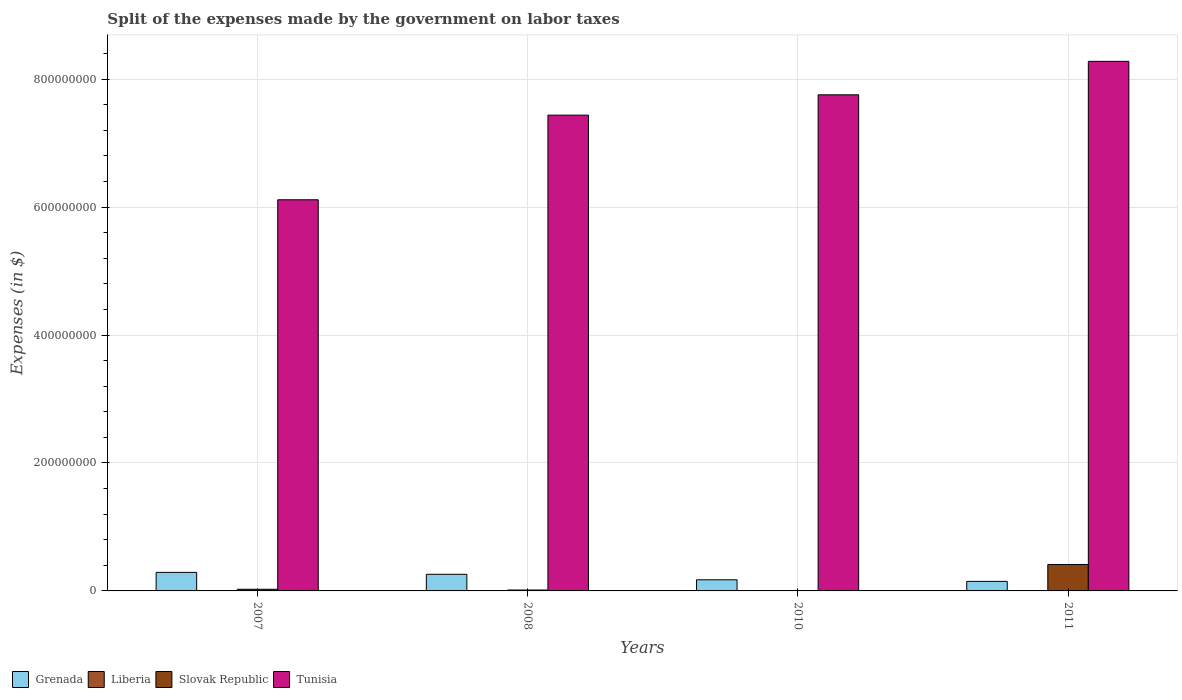How many bars are there on the 3rd tick from the left?
Offer a terse response. 4. What is the label of the 1st group of bars from the left?
Give a very brief answer. 2007. What is the expenses made by the government on labor taxes in Liberia in 2011?
Keep it short and to the point. 1.69e+05. Across all years, what is the maximum expenses made by the government on labor taxes in Grenada?
Keep it short and to the point. 2.90e+07. Across all years, what is the minimum expenses made by the government on labor taxes in Grenada?
Keep it short and to the point. 1.49e+07. What is the total expenses made by the government on labor taxes in Liberia in the graph?
Offer a very short reply. 3.91e+05. What is the difference between the expenses made by the government on labor taxes in Liberia in 2007 and that in 2011?
Your answer should be compact. -1.54e+05. What is the difference between the expenses made by the government on labor taxes in Grenada in 2011 and the expenses made by the government on labor taxes in Slovak Republic in 2010?
Provide a succinct answer. 1.45e+07. What is the average expenses made by the government on labor taxes in Grenada per year?
Ensure brevity in your answer.  2.18e+07. In the year 2010, what is the difference between the expenses made by the government on labor taxes in Liberia and expenses made by the government on labor taxes in Tunisia?
Your answer should be very brief. -7.75e+08. In how many years, is the expenses made by the government on labor taxes in Tunisia greater than 280000000 $?
Your answer should be very brief. 4. What is the ratio of the expenses made by the government on labor taxes in Tunisia in 2007 to that in 2010?
Offer a terse response. 0.79. What is the difference between the highest and the second highest expenses made by the government on labor taxes in Tunisia?
Keep it short and to the point. 5.23e+07. What is the difference between the highest and the lowest expenses made by the government on labor taxes in Grenada?
Your response must be concise. 1.41e+07. In how many years, is the expenses made by the government on labor taxes in Grenada greater than the average expenses made by the government on labor taxes in Grenada taken over all years?
Make the answer very short. 2. Is the sum of the expenses made by the government on labor taxes in Tunisia in 2008 and 2011 greater than the maximum expenses made by the government on labor taxes in Liberia across all years?
Provide a short and direct response. Yes. What does the 4th bar from the left in 2010 represents?
Offer a terse response. Tunisia. What does the 2nd bar from the right in 2011 represents?
Offer a very short reply. Slovak Republic. Is it the case that in every year, the sum of the expenses made by the government on labor taxes in Slovak Republic and expenses made by the government on labor taxes in Grenada is greater than the expenses made by the government on labor taxes in Tunisia?
Provide a succinct answer. No. How many bars are there?
Your answer should be very brief. 16. What is the difference between two consecutive major ticks on the Y-axis?
Ensure brevity in your answer.  2.00e+08. Does the graph contain any zero values?
Your answer should be very brief. No. How many legend labels are there?
Offer a terse response. 4. How are the legend labels stacked?
Give a very brief answer. Horizontal. What is the title of the graph?
Offer a very short reply. Split of the expenses made by the government on labor taxes. What is the label or title of the X-axis?
Provide a short and direct response. Years. What is the label or title of the Y-axis?
Your answer should be compact. Expenses (in $). What is the Expenses (in $) in Grenada in 2007?
Your answer should be compact. 2.90e+07. What is the Expenses (in $) in Liberia in 2007?
Ensure brevity in your answer.  1.49e+04. What is the Expenses (in $) of Slovak Republic in 2007?
Your response must be concise. 2.58e+06. What is the Expenses (in $) in Tunisia in 2007?
Your answer should be very brief. 6.12e+08. What is the Expenses (in $) of Grenada in 2008?
Your answer should be very brief. 2.60e+07. What is the Expenses (in $) in Liberia in 2008?
Provide a short and direct response. 2.34e+04. What is the Expenses (in $) of Slovak Republic in 2008?
Make the answer very short. 1.39e+06. What is the Expenses (in $) in Tunisia in 2008?
Offer a terse response. 7.44e+08. What is the Expenses (in $) of Grenada in 2010?
Your answer should be compact. 1.74e+07. What is the Expenses (in $) of Liberia in 2010?
Offer a terse response. 1.84e+05. What is the Expenses (in $) in Slovak Republic in 2010?
Your answer should be compact. 3.61e+05. What is the Expenses (in $) of Tunisia in 2010?
Your response must be concise. 7.76e+08. What is the Expenses (in $) in Grenada in 2011?
Provide a succinct answer. 1.49e+07. What is the Expenses (in $) of Liberia in 2011?
Make the answer very short. 1.69e+05. What is the Expenses (in $) in Slovak Republic in 2011?
Ensure brevity in your answer.  4.13e+07. What is the Expenses (in $) of Tunisia in 2011?
Ensure brevity in your answer.  8.28e+08. Across all years, what is the maximum Expenses (in $) in Grenada?
Provide a short and direct response. 2.90e+07. Across all years, what is the maximum Expenses (in $) in Liberia?
Your response must be concise. 1.84e+05. Across all years, what is the maximum Expenses (in $) of Slovak Republic?
Provide a succinct answer. 4.13e+07. Across all years, what is the maximum Expenses (in $) of Tunisia?
Give a very brief answer. 8.28e+08. Across all years, what is the minimum Expenses (in $) in Grenada?
Your answer should be compact. 1.49e+07. Across all years, what is the minimum Expenses (in $) of Liberia?
Your response must be concise. 1.49e+04. Across all years, what is the minimum Expenses (in $) in Slovak Republic?
Make the answer very short. 3.61e+05. Across all years, what is the minimum Expenses (in $) in Tunisia?
Offer a terse response. 6.12e+08. What is the total Expenses (in $) in Grenada in the graph?
Give a very brief answer. 8.73e+07. What is the total Expenses (in $) of Liberia in the graph?
Ensure brevity in your answer.  3.91e+05. What is the total Expenses (in $) in Slovak Republic in the graph?
Give a very brief answer. 4.57e+07. What is the total Expenses (in $) in Tunisia in the graph?
Your response must be concise. 2.96e+09. What is the difference between the Expenses (in $) of Grenada in 2007 and that in 2008?
Give a very brief answer. 3.00e+06. What is the difference between the Expenses (in $) in Liberia in 2007 and that in 2008?
Your answer should be very brief. -8521.28. What is the difference between the Expenses (in $) of Slovak Republic in 2007 and that in 2008?
Your answer should be very brief. 1.19e+06. What is the difference between the Expenses (in $) in Tunisia in 2007 and that in 2008?
Your answer should be very brief. -1.32e+08. What is the difference between the Expenses (in $) of Grenada in 2007 and that in 2010?
Offer a very short reply. 1.16e+07. What is the difference between the Expenses (in $) of Liberia in 2007 and that in 2010?
Your answer should be very brief. -1.69e+05. What is the difference between the Expenses (in $) of Slovak Republic in 2007 and that in 2010?
Your answer should be very brief. 2.22e+06. What is the difference between the Expenses (in $) of Tunisia in 2007 and that in 2010?
Provide a short and direct response. -1.64e+08. What is the difference between the Expenses (in $) in Grenada in 2007 and that in 2011?
Provide a succinct answer. 1.41e+07. What is the difference between the Expenses (in $) in Liberia in 2007 and that in 2011?
Ensure brevity in your answer.  -1.54e+05. What is the difference between the Expenses (in $) of Slovak Republic in 2007 and that in 2011?
Your answer should be compact. -3.87e+07. What is the difference between the Expenses (in $) of Tunisia in 2007 and that in 2011?
Offer a very short reply. -2.16e+08. What is the difference between the Expenses (in $) in Grenada in 2008 and that in 2010?
Give a very brief answer. 8.60e+06. What is the difference between the Expenses (in $) of Liberia in 2008 and that in 2010?
Your answer should be compact. -1.61e+05. What is the difference between the Expenses (in $) in Slovak Republic in 2008 and that in 2010?
Ensure brevity in your answer.  1.03e+06. What is the difference between the Expenses (in $) of Tunisia in 2008 and that in 2010?
Provide a short and direct response. -3.18e+07. What is the difference between the Expenses (in $) in Grenada in 2008 and that in 2011?
Make the answer very short. 1.11e+07. What is the difference between the Expenses (in $) in Liberia in 2008 and that in 2011?
Provide a short and direct response. -1.45e+05. What is the difference between the Expenses (in $) of Slovak Republic in 2008 and that in 2011?
Ensure brevity in your answer.  -3.99e+07. What is the difference between the Expenses (in $) of Tunisia in 2008 and that in 2011?
Ensure brevity in your answer.  -8.41e+07. What is the difference between the Expenses (in $) in Grenada in 2010 and that in 2011?
Make the answer very short. 2.50e+06. What is the difference between the Expenses (in $) in Liberia in 2010 and that in 2011?
Your answer should be very brief. 1.55e+04. What is the difference between the Expenses (in $) in Slovak Republic in 2010 and that in 2011?
Offer a very short reply. -4.10e+07. What is the difference between the Expenses (in $) of Tunisia in 2010 and that in 2011?
Your answer should be compact. -5.23e+07. What is the difference between the Expenses (in $) of Grenada in 2007 and the Expenses (in $) of Liberia in 2008?
Give a very brief answer. 2.90e+07. What is the difference between the Expenses (in $) of Grenada in 2007 and the Expenses (in $) of Slovak Republic in 2008?
Give a very brief answer. 2.76e+07. What is the difference between the Expenses (in $) in Grenada in 2007 and the Expenses (in $) in Tunisia in 2008?
Keep it short and to the point. -7.15e+08. What is the difference between the Expenses (in $) of Liberia in 2007 and the Expenses (in $) of Slovak Republic in 2008?
Your response must be concise. -1.38e+06. What is the difference between the Expenses (in $) of Liberia in 2007 and the Expenses (in $) of Tunisia in 2008?
Your answer should be compact. -7.44e+08. What is the difference between the Expenses (in $) in Slovak Republic in 2007 and the Expenses (in $) in Tunisia in 2008?
Offer a terse response. -7.41e+08. What is the difference between the Expenses (in $) in Grenada in 2007 and the Expenses (in $) in Liberia in 2010?
Make the answer very short. 2.88e+07. What is the difference between the Expenses (in $) in Grenada in 2007 and the Expenses (in $) in Slovak Republic in 2010?
Make the answer very short. 2.86e+07. What is the difference between the Expenses (in $) of Grenada in 2007 and the Expenses (in $) of Tunisia in 2010?
Ensure brevity in your answer.  -7.47e+08. What is the difference between the Expenses (in $) of Liberia in 2007 and the Expenses (in $) of Slovak Republic in 2010?
Make the answer very short. -3.46e+05. What is the difference between the Expenses (in $) of Liberia in 2007 and the Expenses (in $) of Tunisia in 2010?
Give a very brief answer. -7.76e+08. What is the difference between the Expenses (in $) in Slovak Republic in 2007 and the Expenses (in $) in Tunisia in 2010?
Make the answer very short. -7.73e+08. What is the difference between the Expenses (in $) in Grenada in 2007 and the Expenses (in $) in Liberia in 2011?
Offer a very short reply. 2.88e+07. What is the difference between the Expenses (in $) of Grenada in 2007 and the Expenses (in $) of Slovak Republic in 2011?
Provide a succinct answer. -1.23e+07. What is the difference between the Expenses (in $) in Grenada in 2007 and the Expenses (in $) in Tunisia in 2011?
Offer a terse response. -7.99e+08. What is the difference between the Expenses (in $) of Liberia in 2007 and the Expenses (in $) of Slovak Republic in 2011?
Give a very brief answer. -4.13e+07. What is the difference between the Expenses (in $) of Liberia in 2007 and the Expenses (in $) of Tunisia in 2011?
Offer a terse response. -8.28e+08. What is the difference between the Expenses (in $) in Slovak Republic in 2007 and the Expenses (in $) in Tunisia in 2011?
Provide a short and direct response. -8.25e+08. What is the difference between the Expenses (in $) of Grenada in 2008 and the Expenses (in $) of Liberia in 2010?
Give a very brief answer. 2.58e+07. What is the difference between the Expenses (in $) of Grenada in 2008 and the Expenses (in $) of Slovak Republic in 2010?
Ensure brevity in your answer.  2.56e+07. What is the difference between the Expenses (in $) in Grenada in 2008 and the Expenses (in $) in Tunisia in 2010?
Ensure brevity in your answer.  -7.50e+08. What is the difference between the Expenses (in $) in Liberia in 2008 and the Expenses (in $) in Slovak Republic in 2010?
Make the answer very short. -3.38e+05. What is the difference between the Expenses (in $) in Liberia in 2008 and the Expenses (in $) in Tunisia in 2010?
Make the answer very short. -7.76e+08. What is the difference between the Expenses (in $) in Slovak Republic in 2008 and the Expenses (in $) in Tunisia in 2010?
Provide a succinct answer. -7.74e+08. What is the difference between the Expenses (in $) in Grenada in 2008 and the Expenses (in $) in Liberia in 2011?
Offer a very short reply. 2.58e+07. What is the difference between the Expenses (in $) of Grenada in 2008 and the Expenses (in $) of Slovak Republic in 2011?
Give a very brief answer. -1.53e+07. What is the difference between the Expenses (in $) in Grenada in 2008 and the Expenses (in $) in Tunisia in 2011?
Offer a very short reply. -8.02e+08. What is the difference between the Expenses (in $) in Liberia in 2008 and the Expenses (in $) in Slovak Republic in 2011?
Your answer should be compact. -4.13e+07. What is the difference between the Expenses (in $) in Liberia in 2008 and the Expenses (in $) in Tunisia in 2011?
Your answer should be very brief. -8.28e+08. What is the difference between the Expenses (in $) in Slovak Republic in 2008 and the Expenses (in $) in Tunisia in 2011?
Offer a terse response. -8.27e+08. What is the difference between the Expenses (in $) in Grenada in 2010 and the Expenses (in $) in Liberia in 2011?
Provide a succinct answer. 1.72e+07. What is the difference between the Expenses (in $) in Grenada in 2010 and the Expenses (in $) in Slovak Republic in 2011?
Keep it short and to the point. -2.39e+07. What is the difference between the Expenses (in $) in Grenada in 2010 and the Expenses (in $) in Tunisia in 2011?
Ensure brevity in your answer.  -8.10e+08. What is the difference between the Expenses (in $) of Liberia in 2010 and the Expenses (in $) of Slovak Republic in 2011?
Offer a very short reply. -4.11e+07. What is the difference between the Expenses (in $) in Liberia in 2010 and the Expenses (in $) in Tunisia in 2011?
Provide a succinct answer. -8.28e+08. What is the difference between the Expenses (in $) of Slovak Republic in 2010 and the Expenses (in $) of Tunisia in 2011?
Keep it short and to the point. -8.28e+08. What is the average Expenses (in $) of Grenada per year?
Your answer should be very brief. 2.18e+07. What is the average Expenses (in $) in Liberia per year?
Give a very brief answer. 9.77e+04. What is the average Expenses (in $) in Slovak Republic per year?
Keep it short and to the point. 1.14e+07. What is the average Expenses (in $) of Tunisia per year?
Give a very brief answer. 7.40e+08. In the year 2007, what is the difference between the Expenses (in $) in Grenada and Expenses (in $) in Liberia?
Make the answer very short. 2.90e+07. In the year 2007, what is the difference between the Expenses (in $) of Grenada and Expenses (in $) of Slovak Republic?
Your answer should be compact. 2.64e+07. In the year 2007, what is the difference between the Expenses (in $) in Grenada and Expenses (in $) in Tunisia?
Give a very brief answer. -5.82e+08. In the year 2007, what is the difference between the Expenses (in $) of Liberia and Expenses (in $) of Slovak Republic?
Offer a terse response. -2.57e+06. In the year 2007, what is the difference between the Expenses (in $) of Liberia and Expenses (in $) of Tunisia?
Offer a very short reply. -6.11e+08. In the year 2007, what is the difference between the Expenses (in $) in Slovak Republic and Expenses (in $) in Tunisia?
Provide a succinct answer. -6.09e+08. In the year 2008, what is the difference between the Expenses (in $) in Grenada and Expenses (in $) in Liberia?
Give a very brief answer. 2.60e+07. In the year 2008, what is the difference between the Expenses (in $) in Grenada and Expenses (in $) in Slovak Republic?
Ensure brevity in your answer.  2.46e+07. In the year 2008, what is the difference between the Expenses (in $) in Grenada and Expenses (in $) in Tunisia?
Offer a very short reply. -7.18e+08. In the year 2008, what is the difference between the Expenses (in $) in Liberia and Expenses (in $) in Slovak Republic?
Keep it short and to the point. -1.37e+06. In the year 2008, what is the difference between the Expenses (in $) of Liberia and Expenses (in $) of Tunisia?
Give a very brief answer. -7.44e+08. In the year 2008, what is the difference between the Expenses (in $) of Slovak Republic and Expenses (in $) of Tunisia?
Your response must be concise. -7.42e+08. In the year 2010, what is the difference between the Expenses (in $) in Grenada and Expenses (in $) in Liberia?
Ensure brevity in your answer.  1.72e+07. In the year 2010, what is the difference between the Expenses (in $) of Grenada and Expenses (in $) of Slovak Republic?
Your answer should be very brief. 1.70e+07. In the year 2010, what is the difference between the Expenses (in $) of Grenada and Expenses (in $) of Tunisia?
Offer a very short reply. -7.58e+08. In the year 2010, what is the difference between the Expenses (in $) of Liberia and Expenses (in $) of Slovak Republic?
Give a very brief answer. -1.77e+05. In the year 2010, what is the difference between the Expenses (in $) of Liberia and Expenses (in $) of Tunisia?
Make the answer very short. -7.75e+08. In the year 2010, what is the difference between the Expenses (in $) of Slovak Republic and Expenses (in $) of Tunisia?
Offer a terse response. -7.75e+08. In the year 2011, what is the difference between the Expenses (in $) of Grenada and Expenses (in $) of Liberia?
Your response must be concise. 1.47e+07. In the year 2011, what is the difference between the Expenses (in $) of Grenada and Expenses (in $) of Slovak Republic?
Offer a very short reply. -2.64e+07. In the year 2011, what is the difference between the Expenses (in $) of Grenada and Expenses (in $) of Tunisia?
Provide a short and direct response. -8.13e+08. In the year 2011, what is the difference between the Expenses (in $) in Liberia and Expenses (in $) in Slovak Republic?
Your answer should be very brief. -4.12e+07. In the year 2011, what is the difference between the Expenses (in $) of Liberia and Expenses (in $) of Tunisia?
Provide a succinct answer. -8.28e+08. In the year 2011, what is the difference between the Expenses (in $) of Slovak Republic and Expenses (in $) of Tunisia?
Offer a terse response. -7.87e+08. What is the ratio of the Expenses (in $) in Grenada in 2007 to that in 2008?
Provide a short and direct response. 1.12. What is the ratio of the Expenses (in $) of Liberia in 2007 to that in 2008?
Ensure brevity in your answer.  0.64. What is the ratio of the Expenses (in $) in Slovak Republic in 2007 to that in 2008?
Offer a terse response. 1.86. What is the ratio of the Expenses (in $) of Tunisia in 2007 to that in 2008?
Offer a very short reply. 0.82. What is the ratio of the Expenses (in $) in Grenada in 2007 to that in 2010?
Your answer should be very brief. 1.67. What is the ratio of the Expenses (in $) in Liberia in 2007 to that in 2010?
Provide a short and direct response. 0.08. What is the ratio of the Expenses (in $) of Slovak Republic in 2007 to that in 2010?
Your response must be concise. 7.15. What is the ratio of the Expenses (in $) of Tunisia in 2007 to that in 2010?
Make the answer very short. 0.79. What is the ratio of the Expenses (in $) in Grenada in 2007 to that in 2011?
Your answer should be very brief. 1.95. What is the ratio of the Expenses (in $) in Liberia in 2007 to that in 2011?
Make the answer very short. 0.09. What is the ratio of the Expenses (in $) in Slovak Republic in 2007 to that in 2011?
Offer a terse response. 0.06. What is the ratio of the Expenses (in $) in Tunisia in 2007 to that in 2011?
Offer a very short reply. 0.74. What is the ratio of the Expenses (in $) of Grenada in 2008 to that in 2010?
Your response must be concise. 1.49. What is the ratio of the Expenses (in $) of Liberia in 2008 to that in 2010?
Offer a terse response. 0.13. What is the ratio of the Expenses (in $) of Slovak Republic in 2008 to that in 2010?
Offer a terse response. 3.85. What is the ratio of the Expenses (in $) of Tunisia in 2008 to that in 2010?
Your response must be concise. 0.96. What is the ratio of the Expenses (in $) of Grenada in 2008 to that in 2011?
Offer a terse response. 1.75. What is the ratio of the Expenses (in $) in Liberia in 2008 to that in 2011?
Offer a terse response. 0.14. What is the ratio of the Expenses (in $) in Slovak Republic in 2008 to that in 2011?
Provide a succinct answer. 0.03. What is the ratio of the Expenses (in $) in Tunisia in 2008 to that in 2011?
Give a very brief answer. 0.9. What is the ratio of the Expenses (in $) in Grenada in 2010 to that in 2011?
Offer a very short reply. 1.17. What is the ratio of the Expenses (in $) in Liberia in 2010 to that in 2011?
Provide a succinct answer. 1.09. What is the ratio of the Expenses (in $) of Slovak Republic in 2010 to that in 2011?
Your answer should be very brief. 0.01. What is the ratio of the Expenses (in $) in Tunisia in 2010 to that in 2011?
Keep it short and to the point. 0.94. What is the difference between the highest and the second highest Expenses (in $) in Grenada?
Ensure brevity in your answer.  3.00e+06. What is the difference between the highest and the second highest Expenses (in $) of Liberia?
Your answer should be compact. 1.55e+04. What is the difference between the highest and the second highest Expenses (in $) of Slovak Republic?
Your answer should be very brief. 3.87e+07. What is the difference between the highest and the second highest Expenses (in $) in Tunisia?
Your answer should be very brief. 5.23e+07. What is the difference between the highest and the lowest Expenses (in $) in Grenada?
Your answer should be very brief. 1.41e+07. What is the difference between the highest and the lowest Expenses (in $) in Liberia?
Your answer should be compact. 1.69e+05. What is the difference between the highest and the lowest Expenses (in $) in Slovak Republic?
Ensure brevity in your answer.  4.10e+07. What is the difference between the highest and the lowest Expenses (in $) in Tunisia?
Give a very brief answer. 2.16e+08. 